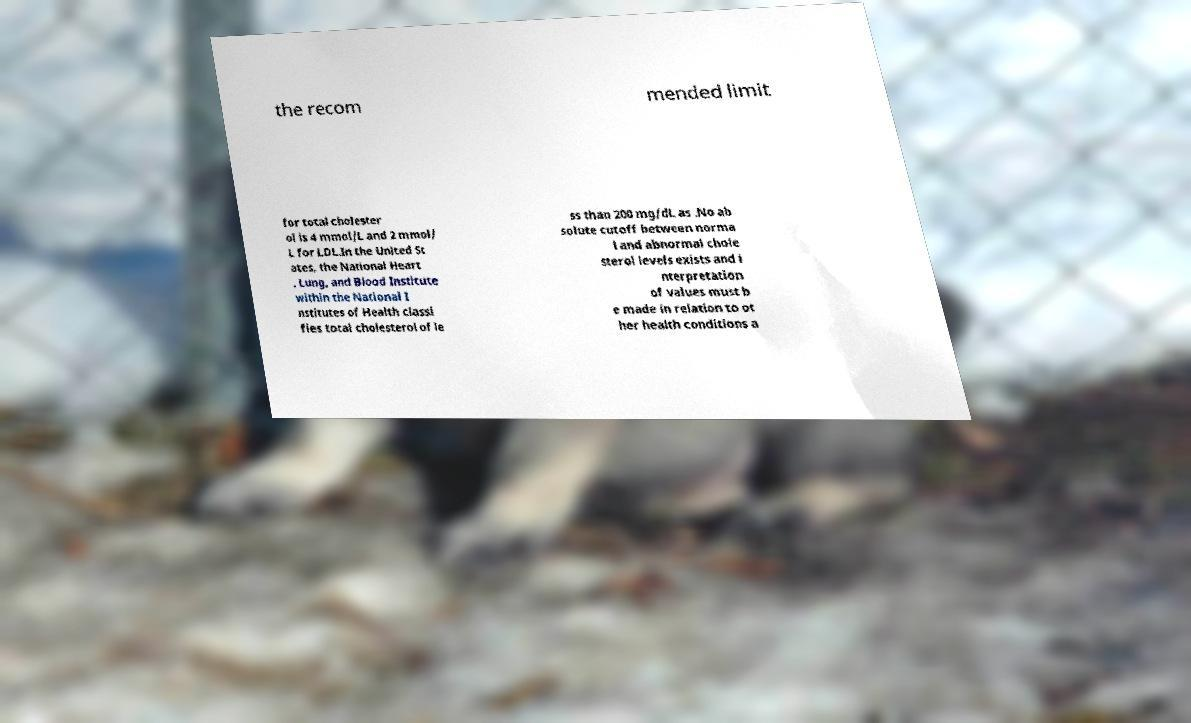Please identify and transcribe the text found in this image. the recom mended limit for total cholester ol is 4 mmol/L and 2 mmol/ L for LDL.In the United St ates, the National Heart , Lung, and Blood Institute within the National I nstitutes of Health classi fies total cholesterol of le ss than 200 mg/dL as .No ab solute cutoff between norma l and abnormal chole sterol levels exists and i nterpretation of values must b e made in relation to ot her health conditions a 